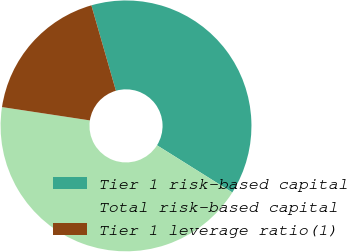Convert chart. <chart><loc_0><loc_0><loc_500><loc_500><pie_chart><fcel>Tier 1 risk-based capital<fcel>Total risk-based capital<fcel>Tier 1 leverage ratio(1)<nl><fcel>38.36%<fcel>43.49%<fcel>18.15%<nl></chart> 